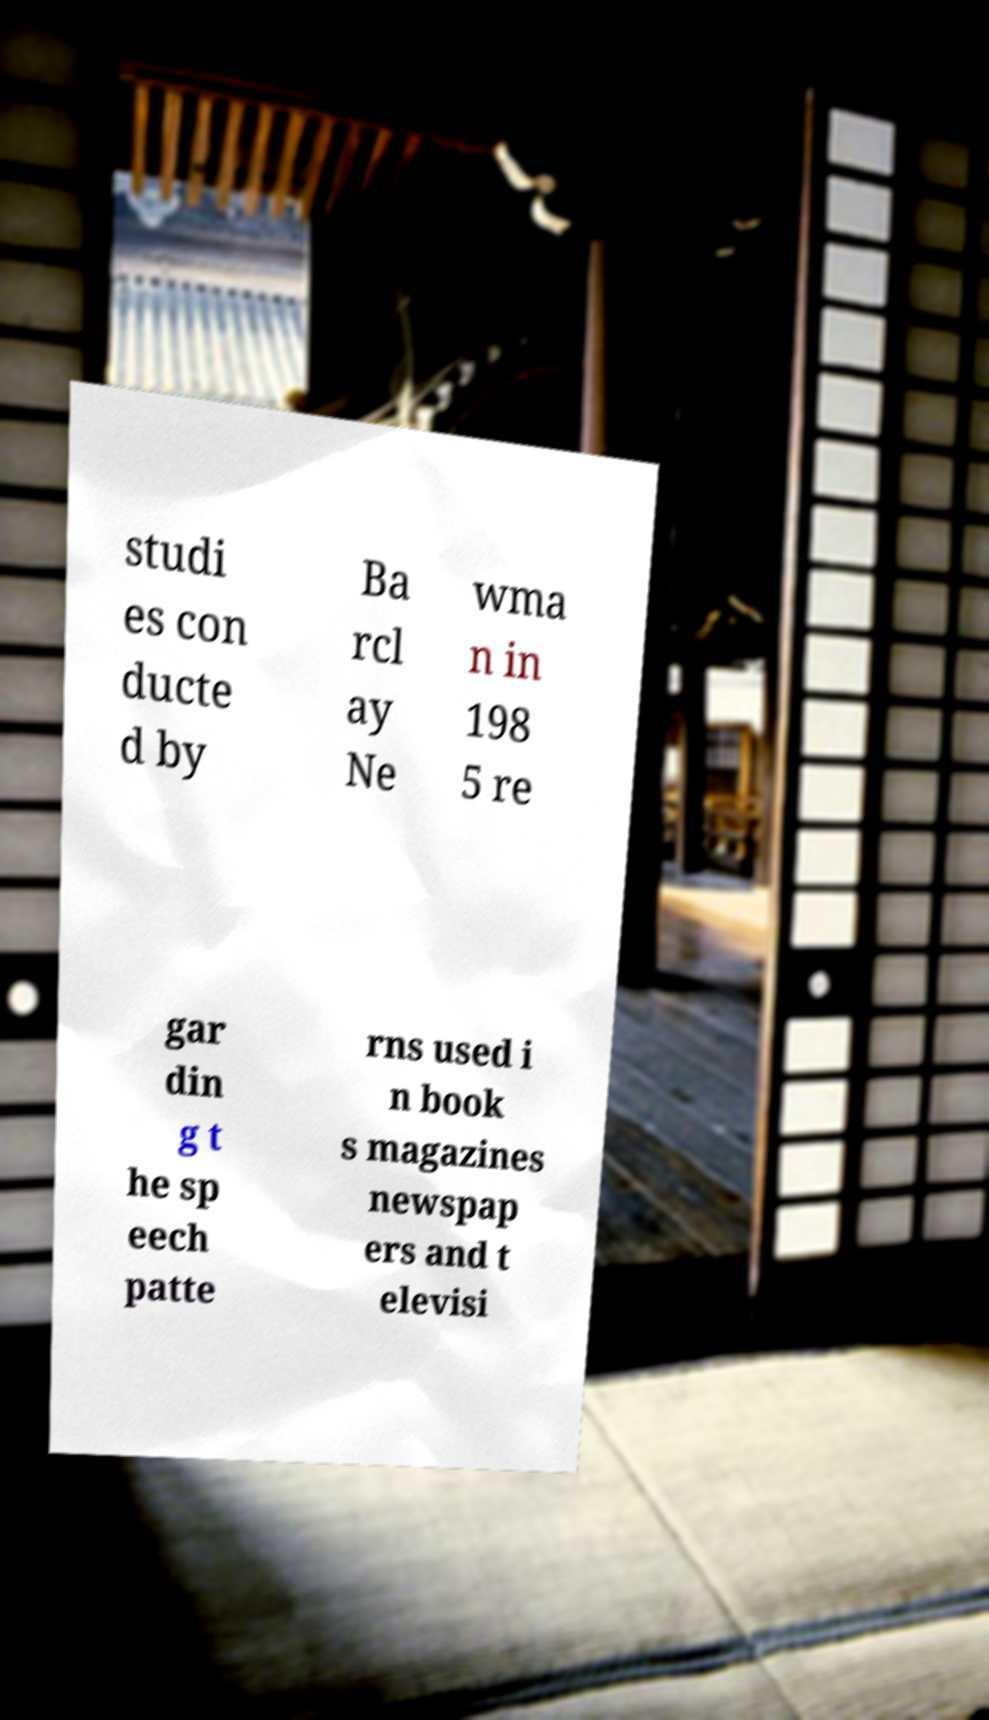Could you assist in decoding the text presented in this image and type it out clearly? studi es con ducte d by Ba rcl ay Ne wma n in 198 5 re gar din g t he sp eech patte rns used i n book s magazines newspap ers and t elevisi 